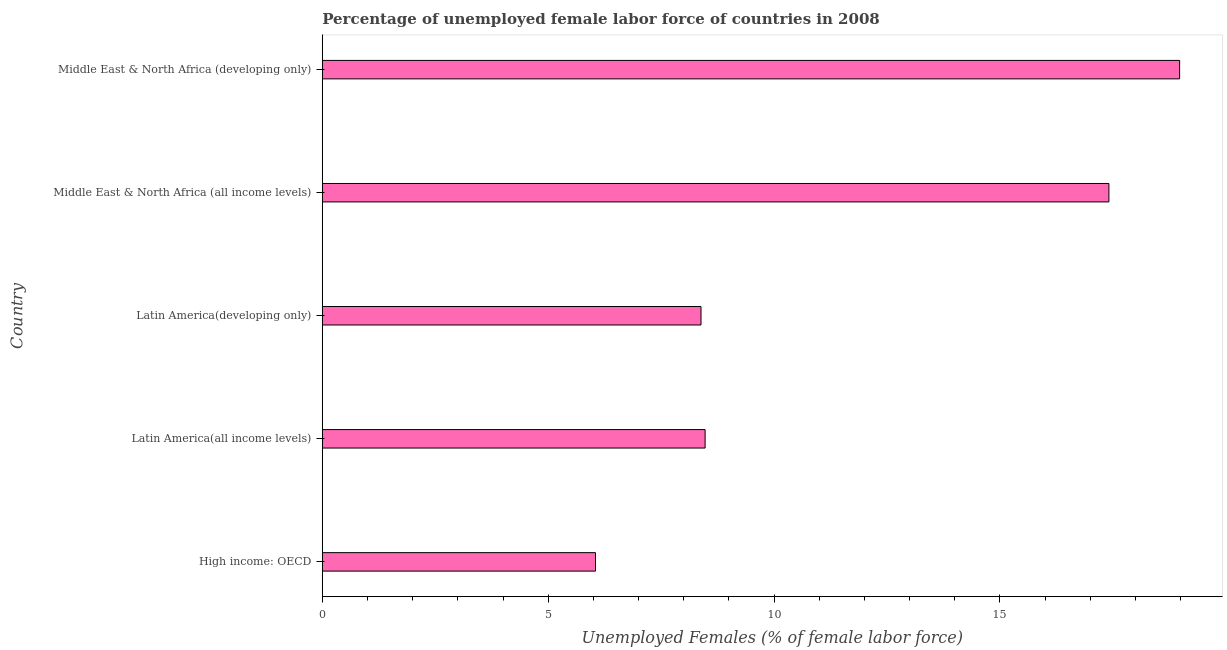Does the graph contain any zero values?
Make the answer very short. No. What is the title of the graph?
Your response must be concise. Percentage of unemployed female labor force of countries in 2008. What is the label or title of the X-axis?
Make the answer very short. Unemployed Females (% of female labor force). What is the total unemployed female labour force in Middle East & North Africa (all income levels)?
Your response must be concise. 17.41. Across all countries, what is the maximum total unemployed female labour force?
Keep it short and to the point. 18.98. Across all countries, what is the minimum total unemployed female labour force?
Offer a very short reply. 6.05. In which country was the total unemployed female labour force maximum?
Your response must be concise. Middle East & North Africa (developing only). In which country was the total unemployed female labour force minimum?
Your answer should be very brief. High income: OECD. What is the sum of the total unemployed female labour force?
Your response must be concise. 59.3. What is the difference between the total unemployed female labour force in High income: OECD and Latin America(developing only)?
Your response must be concise. -2.34. What is the average total unemployed female labour force per country?
Give a very brief answer. 11.86. What is the median total unemployed female labour force?
Keep it short and to the point. 8.47. What is the ratio of the total unemployed female labour force in Latin America(all income levels) to that in Middle East & North Africa (all income levels)?
Offer a very short reply. 0.49. What is the difference between the highest and the second highest total unemployed female labour force?
Offer a very short reply. 1.57. What is the difference between the highest and the lowest total unemployed female labour force?
Give a very brief answer. 12.93. In how many countries, is the total unemployed female labour force greater than the average total unemployed female labour force taken over all countries?
Keep it short and to the point. 2. How many bars are there?
Provide a succinct answer. 5. How many countries are there in the graph?
Provide a short and direct response. 5. What is the Unemployed Females (% of female labor force) of High income: OECD?
Offer a terse response. 6.05. What is the Unemployed Females (% of female labor force) in Latin America(all income levels)?
Your answer should be very brief. 8.47. What is the Unemployed Females (% of female labor force) in Latin America(developing only)?
Provide a short and direct response. 8.38. What is the Unemployed Females (% of female labor force) in Middle East & North Africa (all income levels)?
Keep it short and to the point. 17.41. What is the Unemployed Females (% of female labor force) in Middle East & North Africa (developing only)?
Keep it short and to the point. 18.98. What is the difference between the Unemployed Females (% of female labor force) in High income: OECD and Latin America(all income levels)?
Your answer should be compact. -2.43. What is the difference between the Unemployed Females (% of female labor force) in High income: OECD and Latin America(developing only)?
Offer a terse response. -2.34. What is the difference between the Unemployed Females (% of female labor force) in High income: OECD and Middle East & North Africa (all income levels)?
Your answer should be compact. -11.37. What is the difference between the Unemployed Females (% of female labor force) in High income: OECD and Middle East & North Africa (developing only)?
Give a very brief answer. -12.93. What is the difference between the Unemployed Females (% of female labor force) in Latin America(all income levels) and Latin America(developing only)?
Offer a very short reply. 0.09. What is the difference between the Unemployed Females (% of female labor force) in Latin America(all income levels) and Middle East & North Africa (all income levels)?
Your response must be concise. -8.94. What is the difference between the Unemployed Females (% of female labor force) in Latin America(all income levels) and Middle East & North Africa (developing only)?
Ensure brevity in your answer.  -10.51. What is the difference between the Unemployed Females (% of female labor force) in Latin America(developing only) and Middle East & North Africa (all income levels)?
Offer a terse response. -9.03. What is the difference between the Unemployed Females (% of female labor force) in Latin America(developing only) and Middle East & North Africa (developing only)?
Keep it short and to the point. -10.6. What is the difference between the Unemployed Females (% of female labor force) in Middle East & North Africa (all income levels) and Middle East & North Africa (developing only)?
Give a very brief answer. -1.57. What is the ratio of the Unemployed Females (% of female labor force) in High income: OECD to that in Latin America(all income levels)?
Your answer should be very brief. 0.71. What is the ratio of the Unemployed Females (% of female labor force) in High income: OECD to that in Latin America(developing only)?
Your response must be concise. 0.72. What is the ratio of the Unemployed Females (% of female labor force) in High income: OECD to that in Middle East & North Africa (all income levels)?
Make the answer very short. 0.35. What is the ratio of the Unemployed Females (% of female labor force) in High income: OECD to that in Middle East & North Africa (developing only)?
Keep it short and to the point. 0.32. What is the ratio of the Unemployed Females (% of female labor force) in Latin America(all income levels) to that in Latin America(developing only)?
Make the answer very short. 1.01. What is the ratio of the Unemployed Females (% of female labor force) in Latin America(all income levels) to that in Middle East & North Africa (all income levels)?
Provide a short and direct response. 0.49. What is the ratio of the Unemployed Females (% of female labor force) in Latin America(all income levels) to that in Middle East & North Africa (developing only)?
Ensure brevity in your answer.  0.45. What is the ratio of the Unemployed Females (% of female labor force) in Latin America(developing only) to that in Middle East & North Africa (all income levels)?
Make the answer very short. 0.48. What is the ratio of the Unemployed Females (% of female labor force) in Latin America(developing only) to that in Middle East & North Africa (developing only)?
Give a very brief answer. 0.44. What is the ratio of the Unemployed Females (% of female labor force) in Middle East & North Africa (all income levels) to that in Middle East & North Africa (developing only)?
Ensure brevity in your answer.  0.92. 